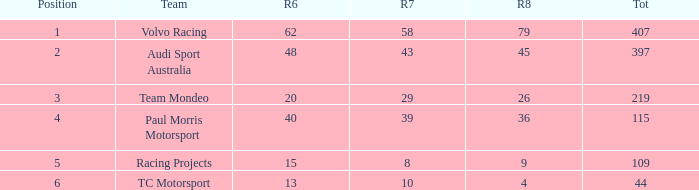What is the sum of values of Rd 7 with RD 6 less than 48 and Rd 8 less than 4 for TC Motorsport in a position greater than 1? None. 